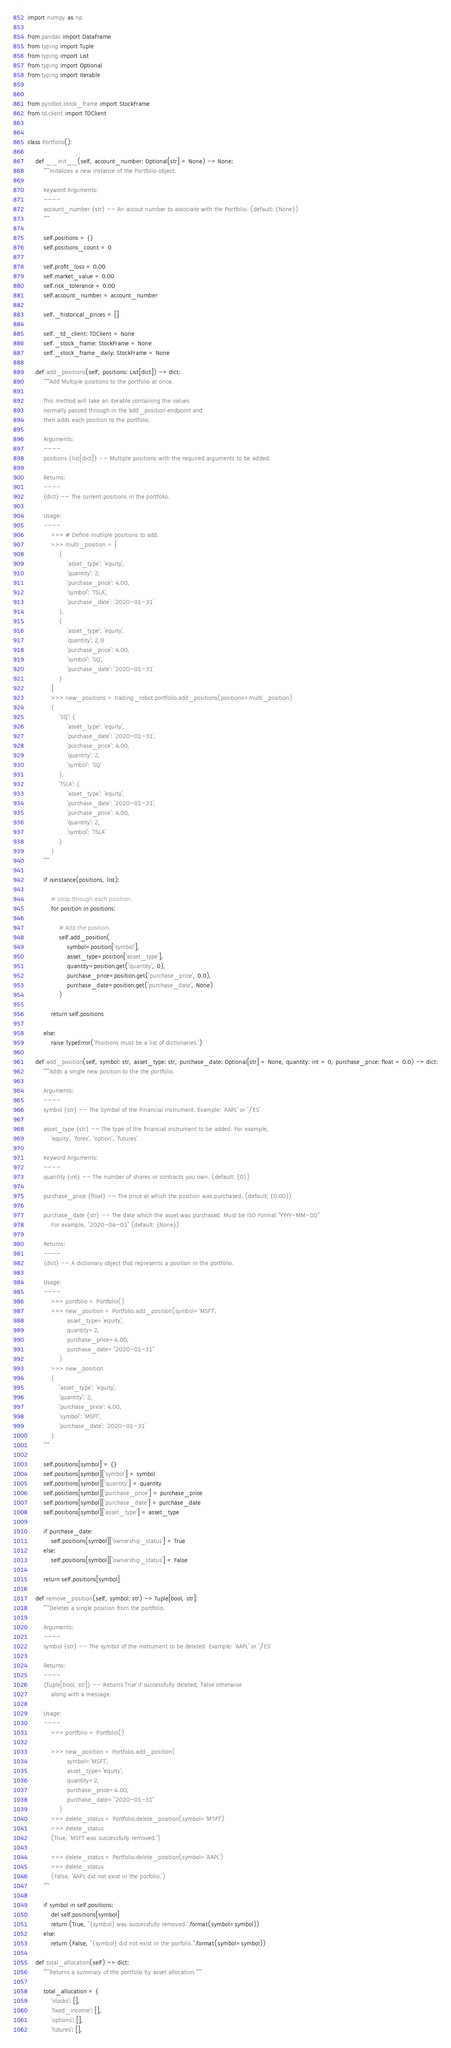<code> <loc_0><loc_0><loc_500><loc_500><_Python_>import numpy as np

from pandas import DataFrame
from typing import Tuple
from typing import List
from typing import Optional
from typing import Iterable


from pyrobot.stock_frame import StockFrame
from td.client import TDClient


class Portfolio():

    def __init__(self, account_number: Optional[str] = None) -> None:
        """Initalizes a new instance of the Portfolio object.

        Keyword Arguments:
        ----
        account_number {str} -- An accout number to associate with the Portfolio. (default: {None})
        """

        self.positions = {}
        self.positions_count = 0

        self.profit_loss = 0.00
        self.market_value = 0.00
        self.risk_tolerance = 0.00
        self.account_number = account_number

        self._historical_prices = []

        self._td_client: TDClient = None
        self._stock_frame: StockFrame = None
        self._stock_frame_daily: StockFrame = None

    def add_positions(self, positions: List[dict]) -> dict:
        """Add Multiple positions to the portfolio at once.

        This method will take an iterable containing the values
        normally passed through in the `add_position` endpoint and
        then adds each position to the portfolio.

        Arguments:
        ----
        positions {list[dict]} -- Multiple positions with the required arguments to be added.

        Returns:
        ----
        {dict} -- The current positions in the portfolio.

        Usage:
        ----
            >>> # Define mutliple positions to add.
            >>> multi_position = [
                {
                    'asset_type': 'equity',
                    'quantity': 2,
                    'purchase_price': 4.00,
                    'symbol': 'TSLA',
                    'purchase_date': '2020-01-31'
                },
                {
                    'asset_type': 'equity',
                    'quantity': 2,0
                    'purchase_price': 4.00,
                    'symbol': 'SQ',
                    'purchase_date': '2020-01-31'
                }
            ]
            >>> new_positions = trading_robot.portfolio.add_positions(positions=multi_position)
            {
                'SQ': {
                    'asset_type': 'equity',
                    'purchase_date': '2020-01-31',
                    'purchase_price': 4.00,
                    'quantity': 2,
                    'symbol': 'SQ'
                },
                'TSLA': {
                    'asset_type': 'equity',
                    'purchase_date': '2020-01-31',
                    'purchase_price': 4.00,
                    'quantity': 2,
                    'symbol': 'TSLA'
                }
            }
        """

        if isinstance(positions, list):

            # Loop through each position.
            for position in positions:

                # Add the position.
                self.add_position(
                    symbol=position['symbol'],
                    asset_type=position['asset_type'],
                    quantity=position.get('quantity', 0),
                    purchase_price=position.get('purchase_price', 0.0),
                    purchase_date=position.get('purchase_date', None)
                )

            return self.positions

        else:
            raise TypeError('Positions must be a list of dictionaries.')

    def add_position(self, symbol: str, asset_type: str, purchase_date: Optional[str] = None, quantity: int = 0, purchase_price: float = 0.0) -> dict:
        """Adds a single new position to the the portfolio.

        Arguments:
        ----
        symbol {str} -- The Symbol of the Financial Instrument. Example: 'AAPL' or '/ES'

        asset_type {str} -- The type of the financial instrument to be added. For example,
            'equity', 'forex', 'option', 'futures'

        Keyword Arguments:
        ----
        quantity {int} -- The number of shares or contracts you own. (default: {0})

        purchase_price {float} -- The price at which the position was purchased. (default: {0.00})

        purchase_date {str} -- The date which the asset was purchased. Must be ISO Format "YYYY-MM-DD"
            For example, "2020-04-01" (default: {None})

        Returns:
        ----
        {dict} -- A dictionary object that represents a position in the portfolio.

        Usage:
        ----
            >>> portfolio = Portfolio()
            >>> new_position = Portfolio.add_position(symbol='MSFT', 
                    asset_type='equity', 
                    quantity=2, 
                    purchase_price=4.00,
                    purchase_date="2020-01-31"
                )
            >>> new_position
            {
                'asset_type': 'equity', 
                'quantity': 2, 
                'purchase_price': 4.00,
                'symbol': 'MSFT',
                'purchase_date': '2020-01-31'
            }
        """

        self.positions[symbol] = {}
        self.positions[symbol]['symbol'] = symbol
        self.positions[symbol]['quantity'] = quantity
        self.positions[symbol]['purchase_price'] = purchase_price
        self.positions[symbol]['purchase_date'] = purchase_date
        self.positions[symbol]['asset_type'] = asset_type

        if purchase_date:
            self.positions[symbol]['ownership_status'] = True
        else:
            self.positions[symbol]['ownership_status'] = False

        return self.positions[symbol]

    def remove_position(self, symbol: str) -> Tuple[bool, str]:
        """Deletes a single position from the portfolio.

        Arguments:
        ----
        symbol {str} -- The symbol of the instrument to be deleted. Example: 'AAPL' or '/ES'

        Returns:
        ----
        {Tuple[bool, str]} -- Returns `True` if successfully deleted, `False` otherwise 
            along with a message.

        Usage:
        ----
            >>> portfolio = Portfolio()

            >>> new_position = Portfolio.add_position(
                    symbol='MSFT', 
                    asset_type='equity', 
                    quantity=2, 
                    purchase_price=4.00,
                    purchase_date="2020-01-31"
                )
            >>> delete_status = Portfolio.delete_position(symbol='MSFT')
            >>> delete_status
            (True, 'MSFT was successfully removed.')

            >>> delete_status = Portfolio.delete_position(symbol='AAPL')
            >>> delete_status
            (False, 'AAPL did not exist in the porfolio.')
        """

        if symbol in self.positions:
            del self.positions[symbol]
            return (True, "{symbol} was successfully removed.".format(symbol=symbol))
        else:
            return (False, "{symbol} did not exist in the porfolio.".format(symbol=symbol))

    def total_allocation(self) -> dict:
        """Returns a summary of the portfolio by asset allocation."""

        total_allocation = {
            'stocks': [],
            'fixed_income': [],
            'options': [],
            'futures': [],</code> 